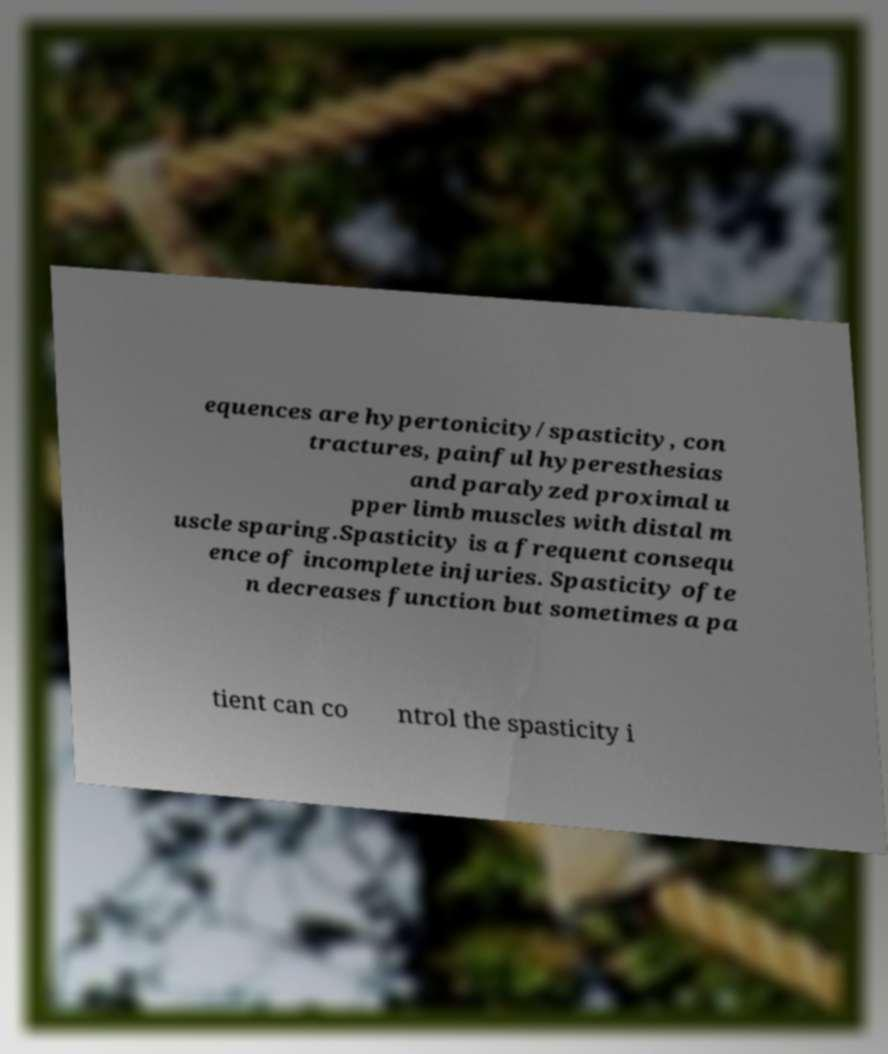Could you assist in decoding the text presented in this image and type it out clearly? equences are hypertonicity/spasticity, con tractures, painful hyperesthesias and paralyzed proximal u pper limb muscles with distal m uscle sparing.Spasticity is a frequent consequ ence of incomplete injuries. Spasticity ofte n decreases function but sometimes a pa tient can co ntrol the spasticity i 